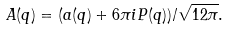<formula> <loc_0><loc_0><loc_500><loc_500>A ( q ) = ( a ( q ) + 6 \pi i P ( q ) ) / \sqrt { 1 2 \pi } .</formula> 